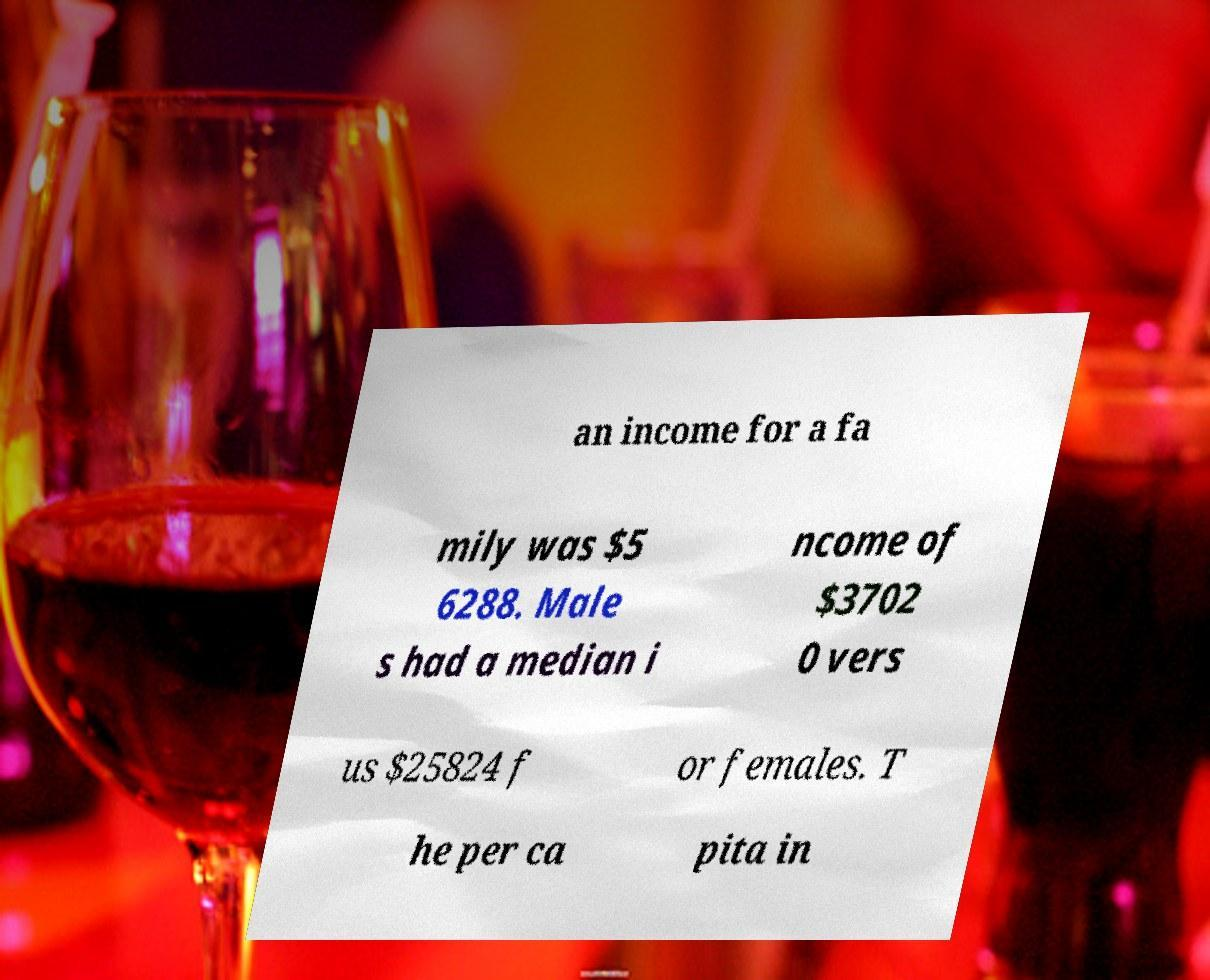Could you extract and type out the text from this image? an income for a fa mily was $5 6288. Male s had a median i ncome of $3702 0 vers us $25824 f or females. T he per ca pita in 